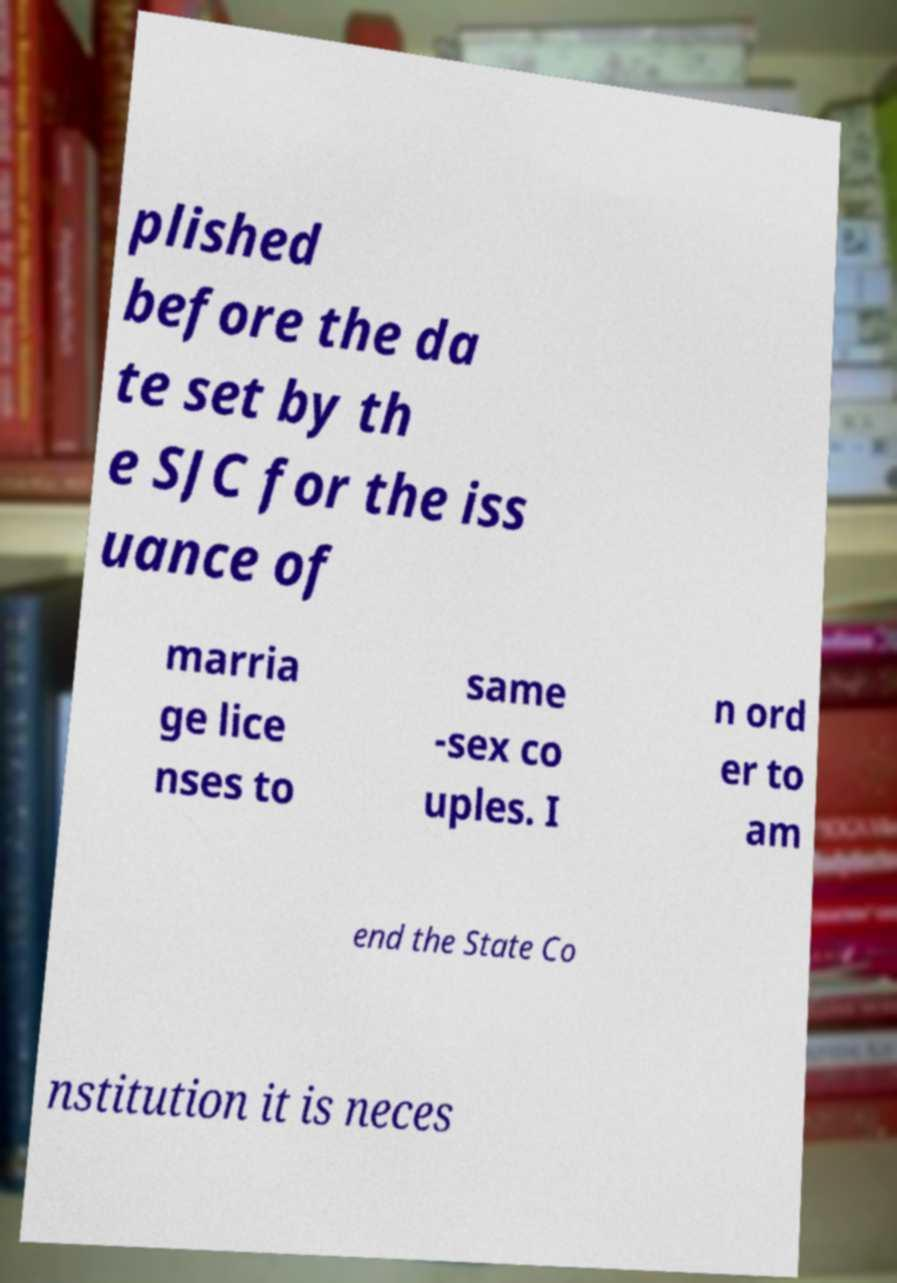Can you accurately transcribe the text from the provided image for me? plished before the da te set by th e SJC for the iss uance of marria ge lice nses to same -sex co uples. I n ord er to am end the State Co nstitution it is neces 